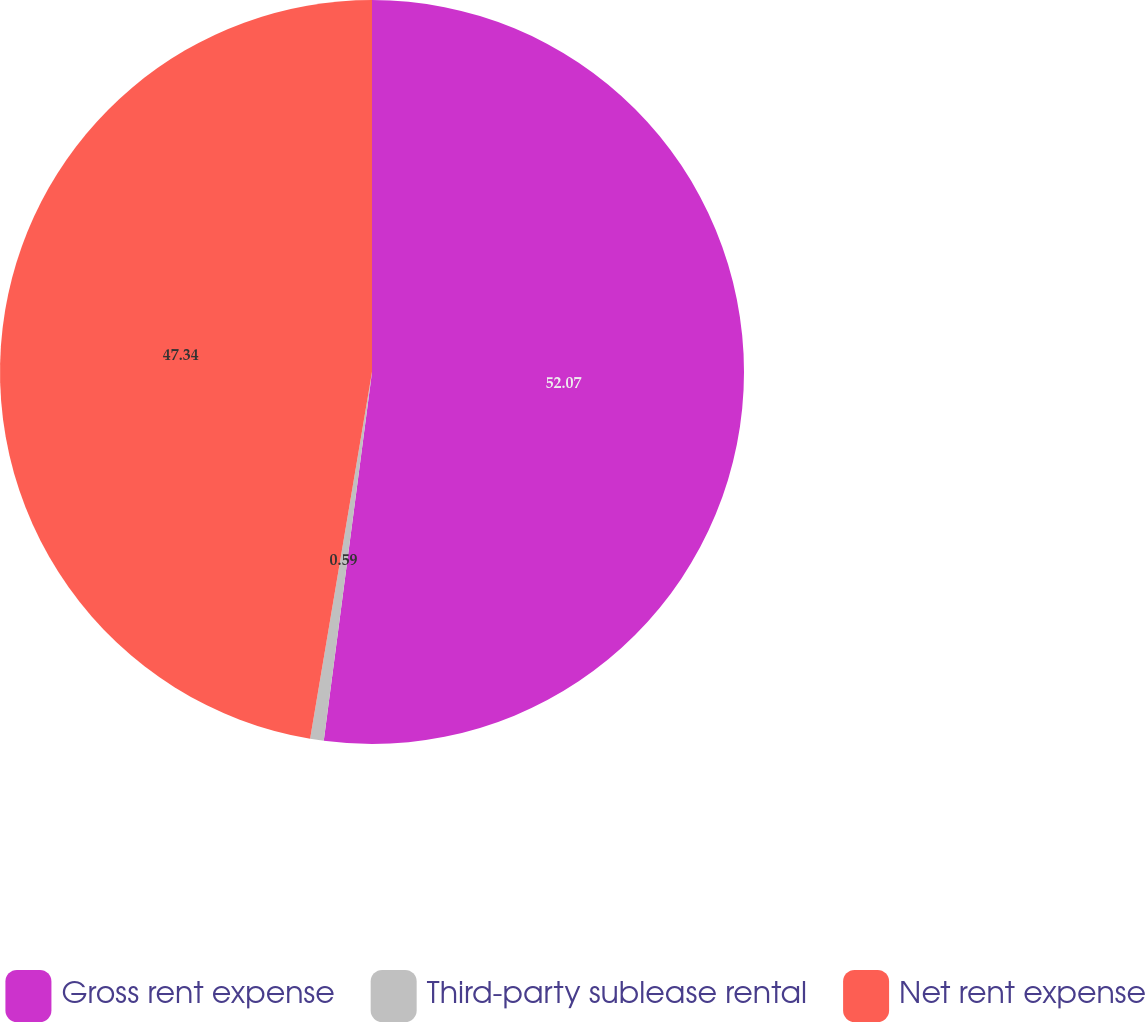Convert chart to OTSL. <chart><loc_0><loc_0><loc_500><loc_500><pie_chart><fcel>Gross rent expense<fcel>Third-party sublease rental<fcel>Net rent expense<nl><fcel>52.07%<fcel>0.59%<fcel>47.34%<nl></chart> 